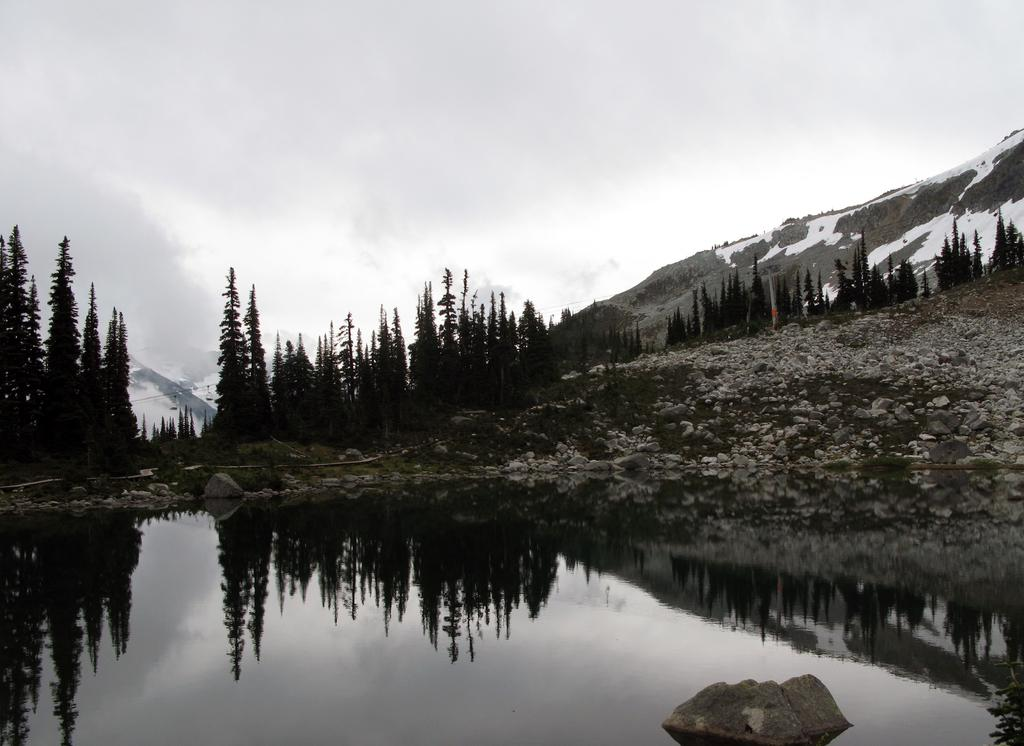What type of natural landform can be seen in the image? There are mountains in the image. What is the ground like in the image? The ground with stones is visible in the image. What body of water is present in the image? There is water in the image. What type of vegetation can be seen in the image? Trees are present in the image. What part of the natural environment is visible in the image? The sky is visible in the image. What is the chance of finding a sea in the image? There is no sea present in the image; it features mountains, water, trees, and a sky. What do people believe about the mountains in the image? The image does not provide any information about people's beliefs regarding the mountains. 